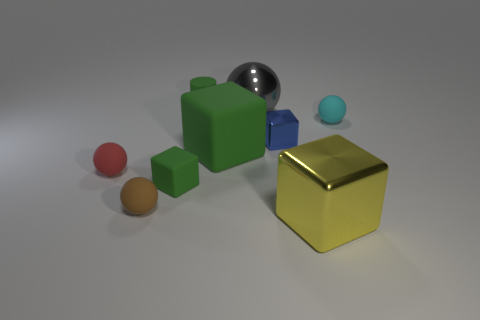What color is the small cylinder?
Keep it short and to the point. Green. Is there a tiny blue rubber cube?
Offer a terse response. No. There is a yellow metal thing; are there any large shiny spheres in front of it?
Provide a short and direct response. No. There is a gray object that is the same shape as the brown object; what is its material?
Provide a short and direct response. Metal. What number of other objects are there of the same shape as the large rubber thing?
Your answer should be very brief. 3. There is a large block that is behind the tiny cube in front of the small blue shiny block; how many big green matte objects are left of it?
Give a very brief answer. 0. How many tiny brown things are the same shape as the big gray object?
Offer a very short reply. 1. There is a matte thing behind the small cyan object; is its color the same as the big shiny sphere?
Your answer should be very brief. No. What is the shape of the big thing in front of the small block that is to the left of the matte thing behind the large gray object?
Offer a very short reply. Cube. Is the size of the gray ball the same as the metallic block that is left of the yellow metallic block?
Provide a short and direct response. No. 